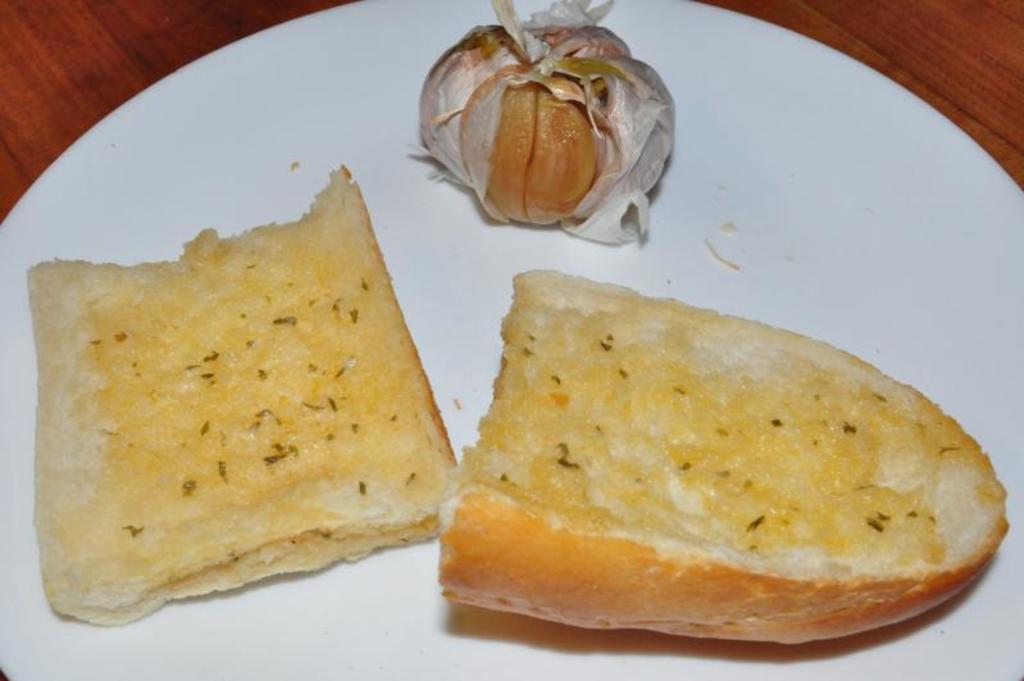In one or two sentences, can you explain what this image depicts? In this picture we can see food items on a plate and this plate is placed on a wooden platform. 